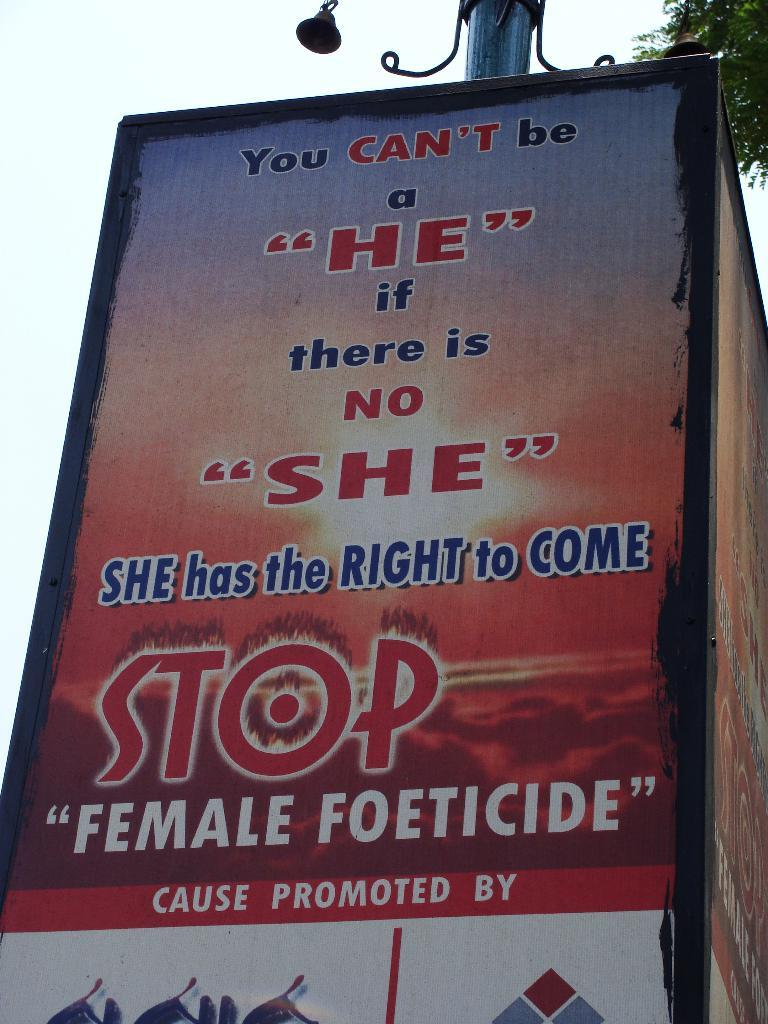<image>
Share a concise interpretation of the image provided. A street sign that reads "Stop Female Foeticide." 